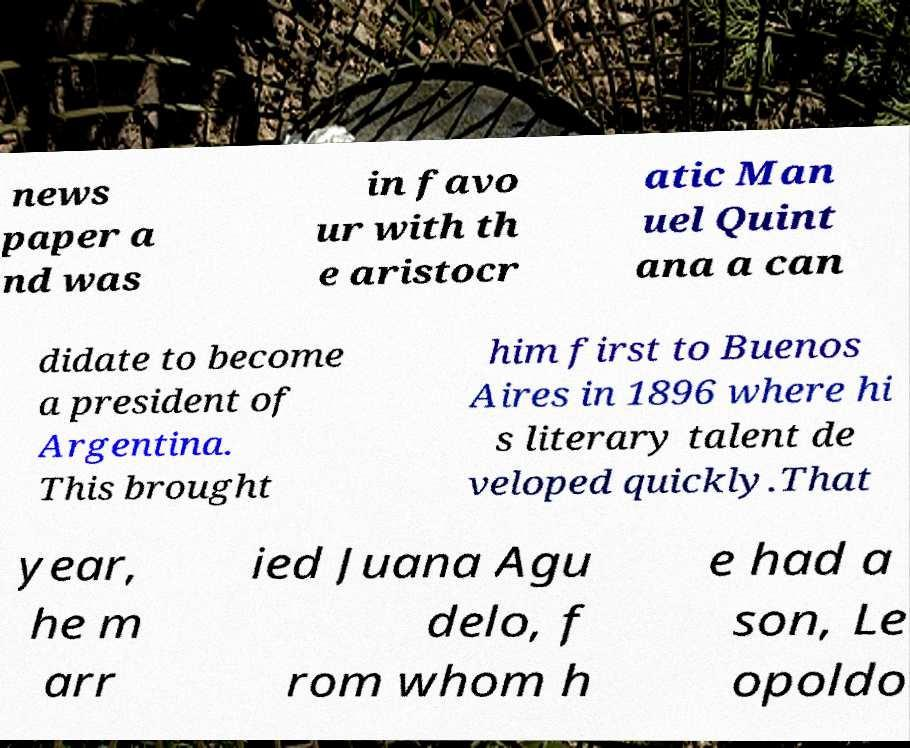For documentation purposes, I need the text within this image transcribed. Could you provide that? news paper a nd was in favo ur with th e aristocr atic Man uel Quint ana a can didate to become a president of Argentina. This brought him first to Buenos Aires in 1896 where hi s literary talent de veloped quickly.That year, he m arr ied Juana Agu delo, f rom whom h e had a son, Le opoldo 